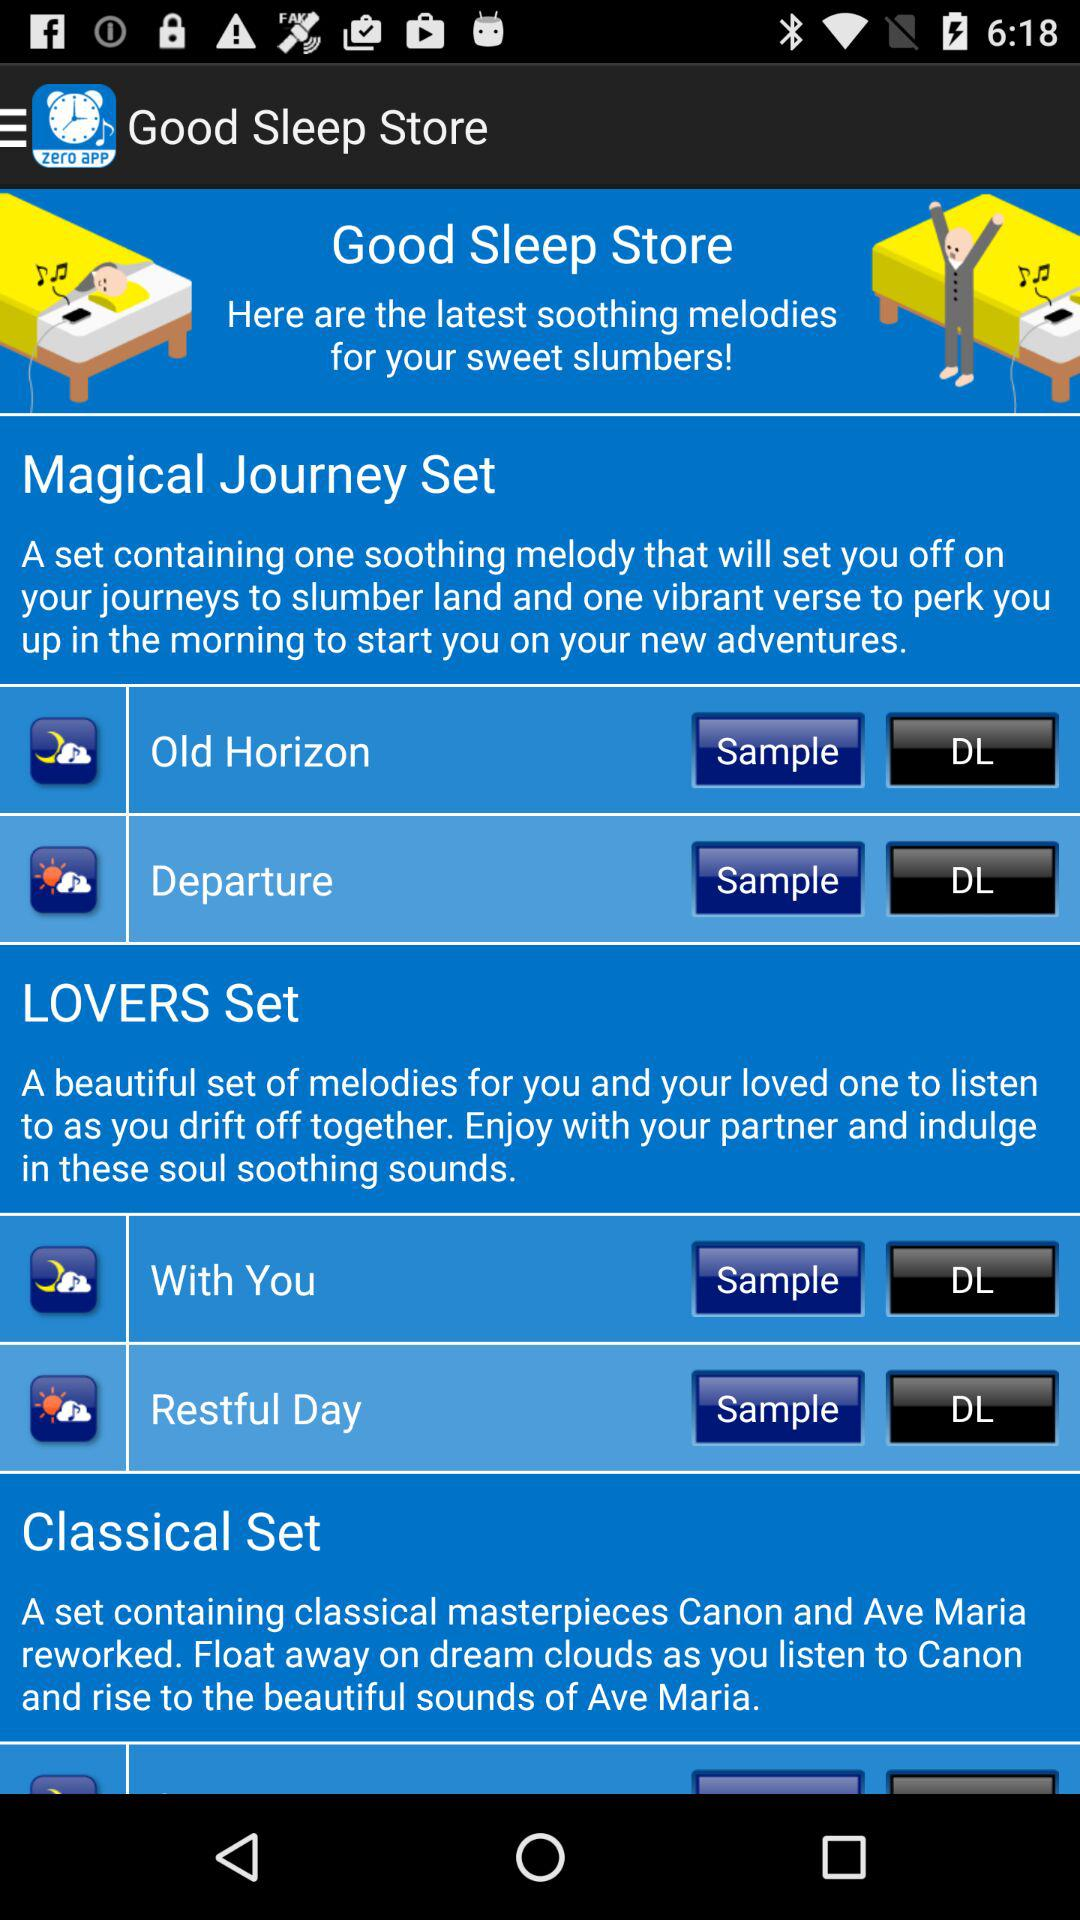How many items are in the LOVERS set?
Answer the question using a single word or phrase. 2 